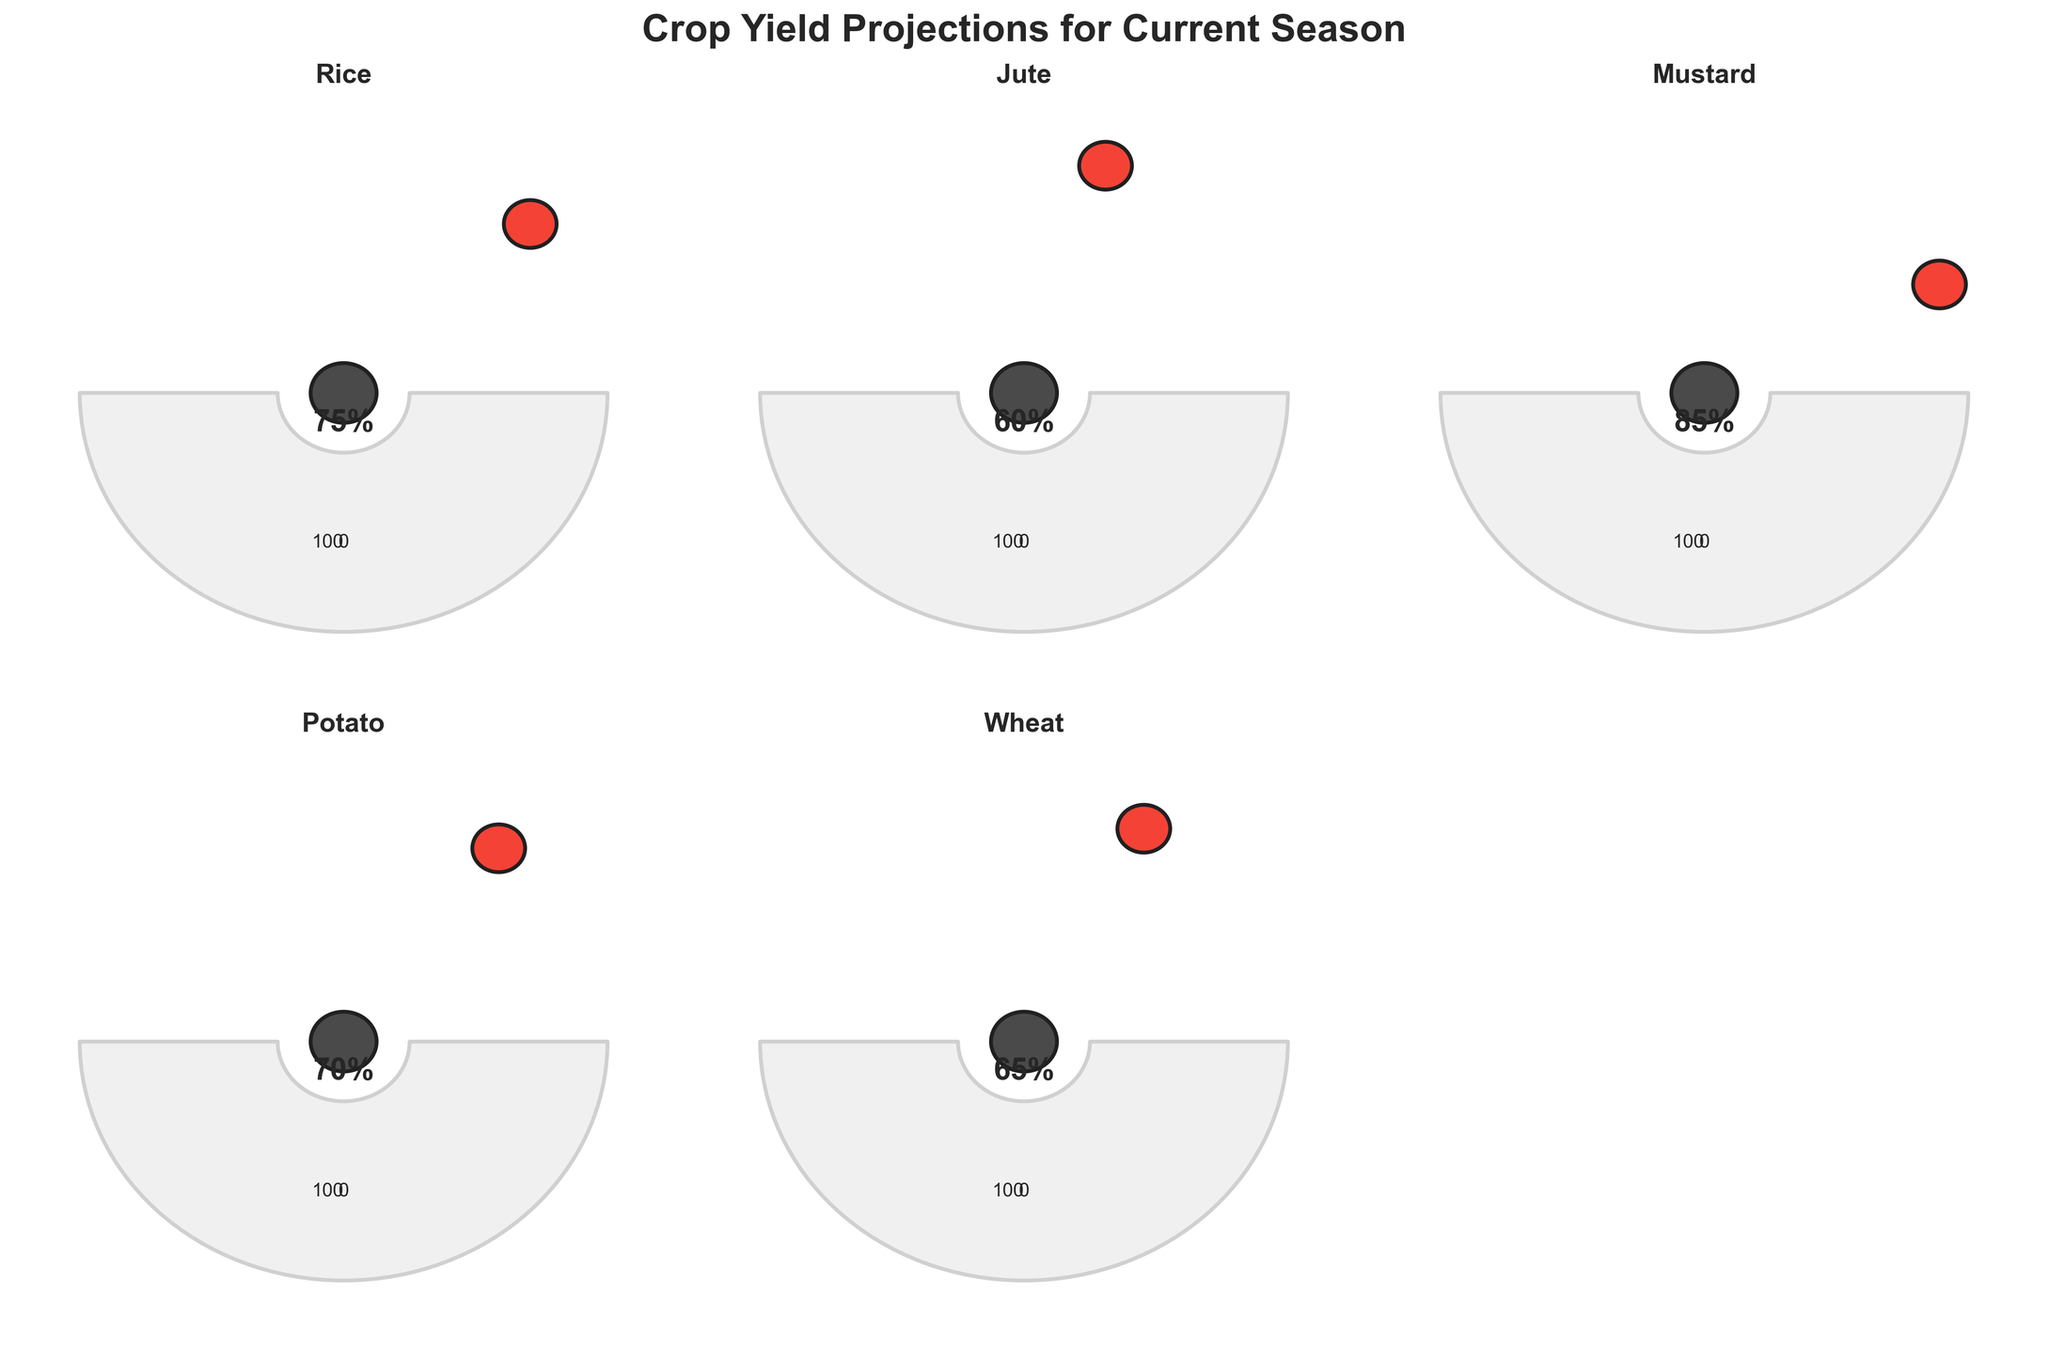What is the projected yield percentage for rice? The gauge chart for rice shows the needle pointing towards 75%, indicating the projected yield.
Answer: 75% Which crop has the lowest projected yield percentage? By examining all the gauge charts, jute has the lowest projected yield at 60%.
Answer: Jute What is the average projected yield percentage across all the crops? Sum the projected yields for each crop (75 + 60 + 85 + 70 + 65) = 355. Divide by the number of crops (5). 355 / 5 = 71.
Answer: 71 Which crop has a higher projected yield, wheat or potato? Wheat has a projected yield of 65% and potato has a projected yield of 70%. Comparing these, potato's projected yield is higher.
Answer: Potato What is the difference in the projected yield between mustard and jute? Mustard has a projected yield of 85% and jute has 60%. The difference is calculated as 85 - 60 = 25.
Answer: 25 Are there any crops with a projected yield greater than 80%? If so, which ones? Mustard is the only crop with a projected yield greater than 80%, specifically at 85%.
Answer: Mustard What is the range of the projected yield percentages shown in the figure? The maximum projected yield is 85% (mustard) and the minimum is 60% (jute). The range is 85 - 60 = 25.
Answer: 25 How many crops have projected yields between 60% and 70%? Jute (60%), potato (70%), and wheat (65%) are all between 60% and 70%. There are three such crops.
Answer: 3 